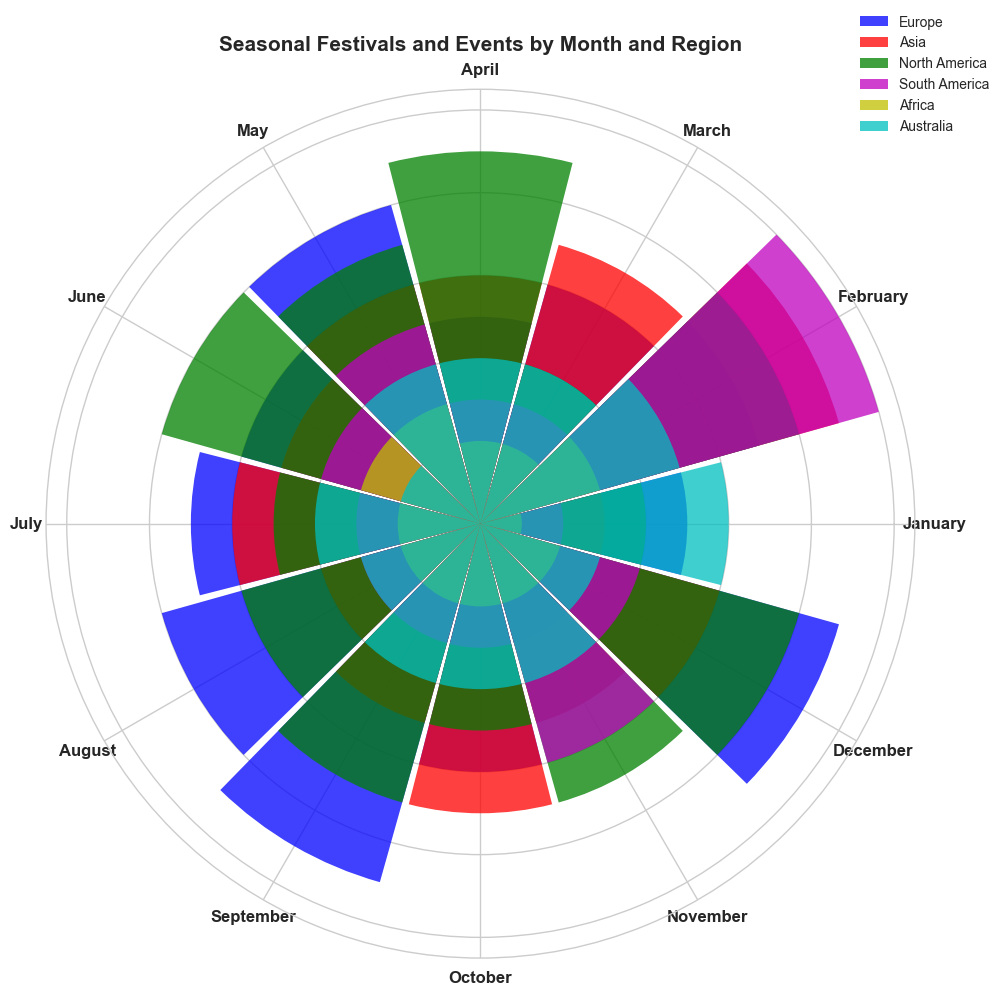Which region has the highest count of events in February? By observing the height of the bars in February, the 'South America' bar is the tallest, indicating the highest number of events.
Answer: South America How many more events are in January in Europe than in Africa? Look at the heights of the bars for Europe and Africa in January. Europe has 5 events and Africa has 1 event. The difference is calculated as 5 - 1.
Answer: 4 Is the count of events in July for North America higher or lower than in January for North America? Compare the bar heights of North America in July and January. July has 5 events, while January has 4 events.
Answer: Higher What is the total count of events in March across all regions? Add the counts of events in March for all regions: Europe (6), Asia (7), North America (4), South America (3), Africa (2), Australia (4). 6 + 7 + 4 + 3 + 2 + 4 = 26.
Answer: 26 In which month does Australia have the maximum number of events? Observe the heights of the bars for Australia across all months and find the tallest one. February has 5 events, which is the maximum.
Answer: February Compare the counts of events in December for Europe and Asia. Which one is higher? Look at the heights of the bars for Europe and Asia in December. Europe has 9 events, while Asia has 6 events.
Answer: Europe What is the difference in the event counts between May and June across all regions? Sum the counts of events for all regions in May and June, then find the difference. May: Europe (8), Asia (6), North America (7), South America (5), Africa (3), Australia (4). Total May events = 8 + 6 + 7 + 5 + 3 + 4 = 33. June: Europe (6), Asia (5), North America (8), South America (4), Africa (3), Australia (2). Total June events = 6 + 5 + 8 + 4 + 3 + 2 = 28. Difference = 33 - 28.
Answer: 5 Do both Africa and South America have the same number of events in October? Compare the heights of the bars for Africa and South America in October to see if they are equal. Both regions have bars of height 2 and 3 respectively.
Answer: No What is the average count of events per month in North America? Sum the counts of events for North America across all months and then divide by the number of months (12). (4+8+4+9+7+8+5+6+7+5+7+8) / 12 = 78 / 12 = 6.5.
Answer: 6.5 